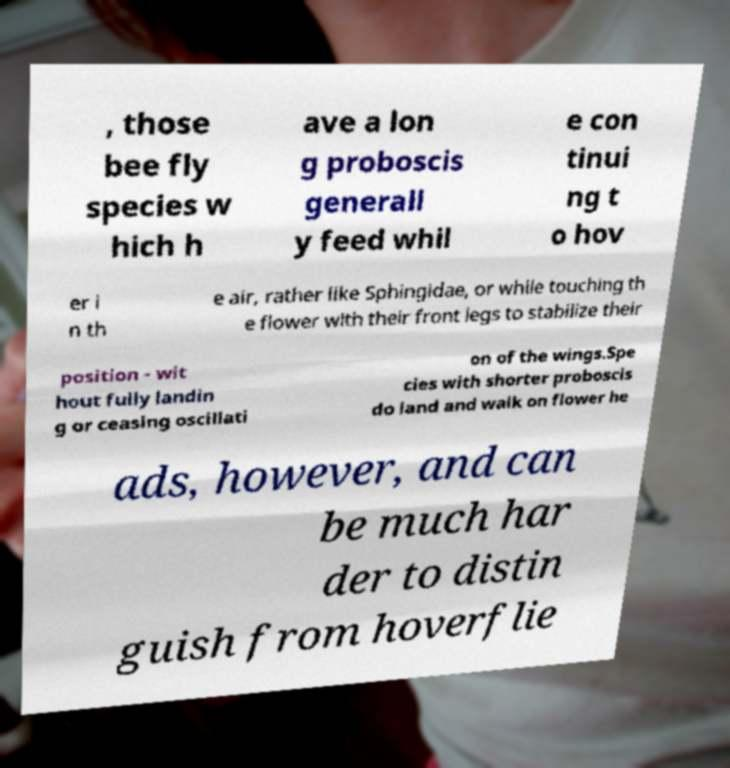I need the written content from this picture converted into text. Can you do that? , those bee fly species w hich h ave a lon g proboscis generall y feed whil e con tinui ng t o hov er i n th e air, rather like Sphingidae, or while touching th e flower with their front legs to stabilize their position - wit hout fully landin g or ceasing oscillati on of the wings.Spe cies with shorter proboscis do land and walk on flower he ads, however, and can be much har der to distin guish from hoverflie 